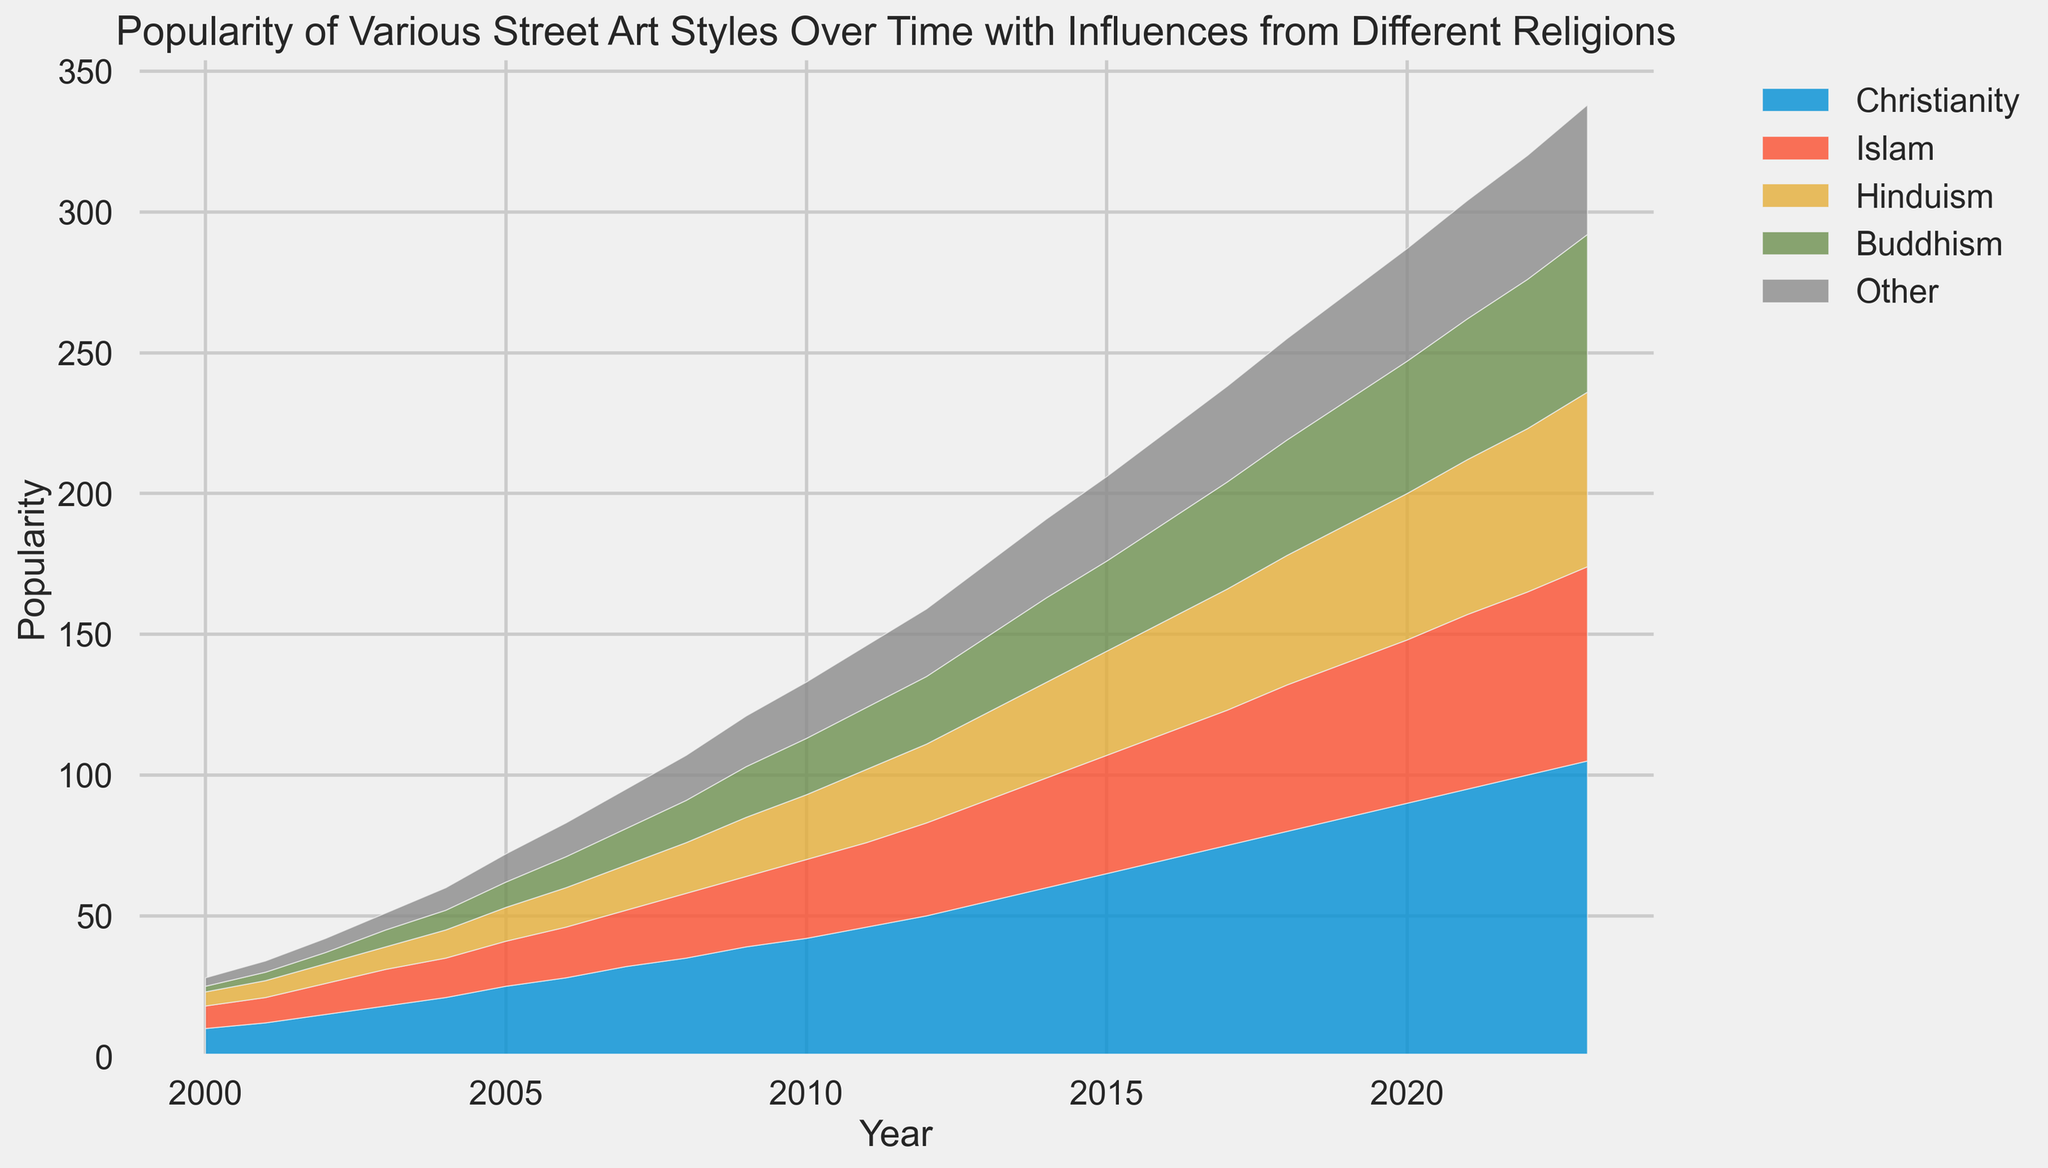How did the popularity of street art influenced by Christianity change from 2000 to 2023? The popularity increased from 10 in 2000 to 105 in 2023.
Answer: Increased from 10 to 105 In what year did the influence of Hinduism surpass the influence of Buddhism in street art popularity? By comparing the data points for Hinduism and Buddhism over the years, we can see that Hinduism's popularity becomes higher than Buddhism's in 2012.
Answer: 2012 Which religion's street art influence shows the most consistent increase over time? By observing the plotted area sections, Christianity's influence shows a consistent and steady increase over the years.
Answer: Christianity What is the cumulative increase in popularity for street art influenced by Islam from 2000 to 2023? The increase is calculated as the end value minus the starting value: 69 (2023) - 8 (2000) = 61.
Answer: 61 In which year did the popularity of street art influenced by Christianity first exceed 50? By examining the Christianity data points, it first exceeds 50 in 2012.
Answer: 2012 Compare the popularity growth rate between Buddhism and Other from 2000 to 2023. Buddhism grew from 2 to 56, a increase of 54, while Other grew from 3 to 46, an increase of 43. The growth rate for Buddhism is higher.
Answer: Buddhism has a higher growth rate By how much did the popularity of street art influenced by Hinduism increase between 2010 and 2020? The popularity increased from 23 in 2010 to 52 in 2020, which is an increase of 29.
Answer: 29 What is the total popularity of street art influenced by religions other than Christianity in 2015? Sum the values for Islam, Hinduism, Buddhism, and Other in 2015: 42 + 37 + 32 + 30 = 141.
Answer: 141 Which religion saw the largest absolute increase in street art influence from 2005 to 2010? Calculate the difference for each religion: Christianity (42-25=17), Islam (28-16=12), Hinduism (23-12=11), Buddhism (20-9=11), Other (20-10=10); the largest increase is Christianity with 17.
Answer: Christianity 